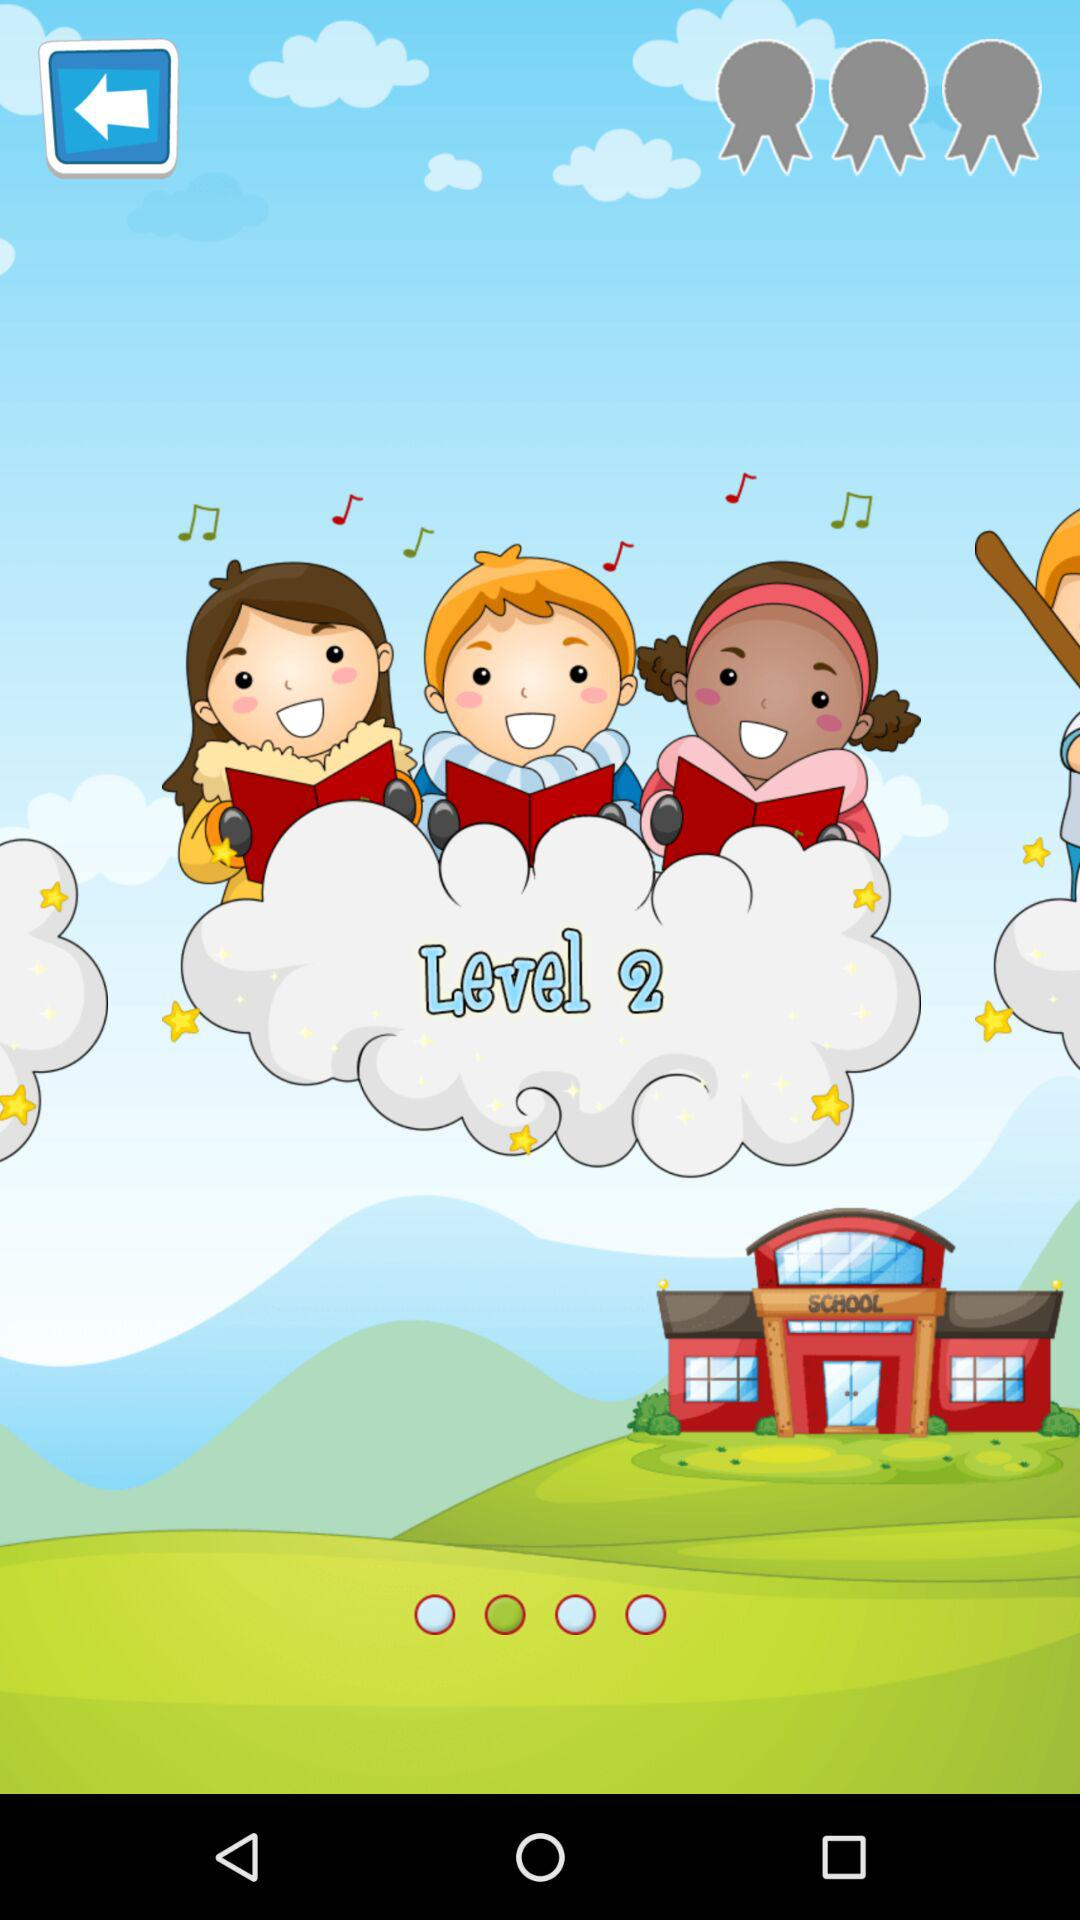What levels are shown there? The shown level is 2. 